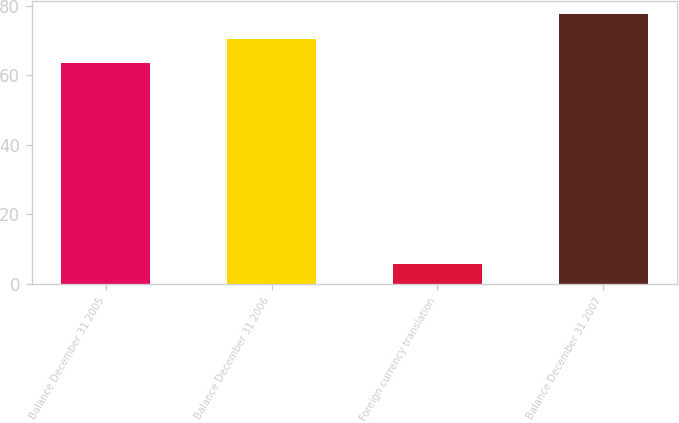Convert chart. <chart><loc_0><loc_0><loc_500><loc_500><bar_chart><fcel>Balance December 31 2005<fcel>Balance December 31 2006<fcel>Foreign currency translation<fcel>Balance December 31 2007<nl><fcel>63.6<fcel>70.54<fcel>5.7<fcel>77.48<nl></chart> 